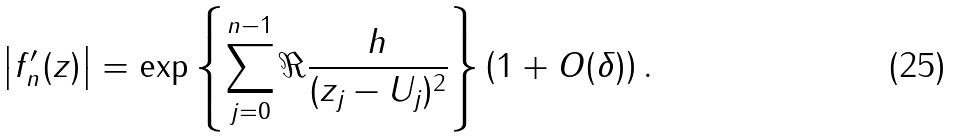<formula> <loc_0><loc_0><loc_500><loc_500>\left | f _ { n } ^ { \prime } ( z ) \right | = \exp \left \{ \sum _ { j = 0 } ^ { n - 1 } \Re \frac { h } { ( z _ { j } - U _ { j } ) ^ { 2 } } \right \} \left ( 1 + O ( \delta ) \right ) .</formula> 